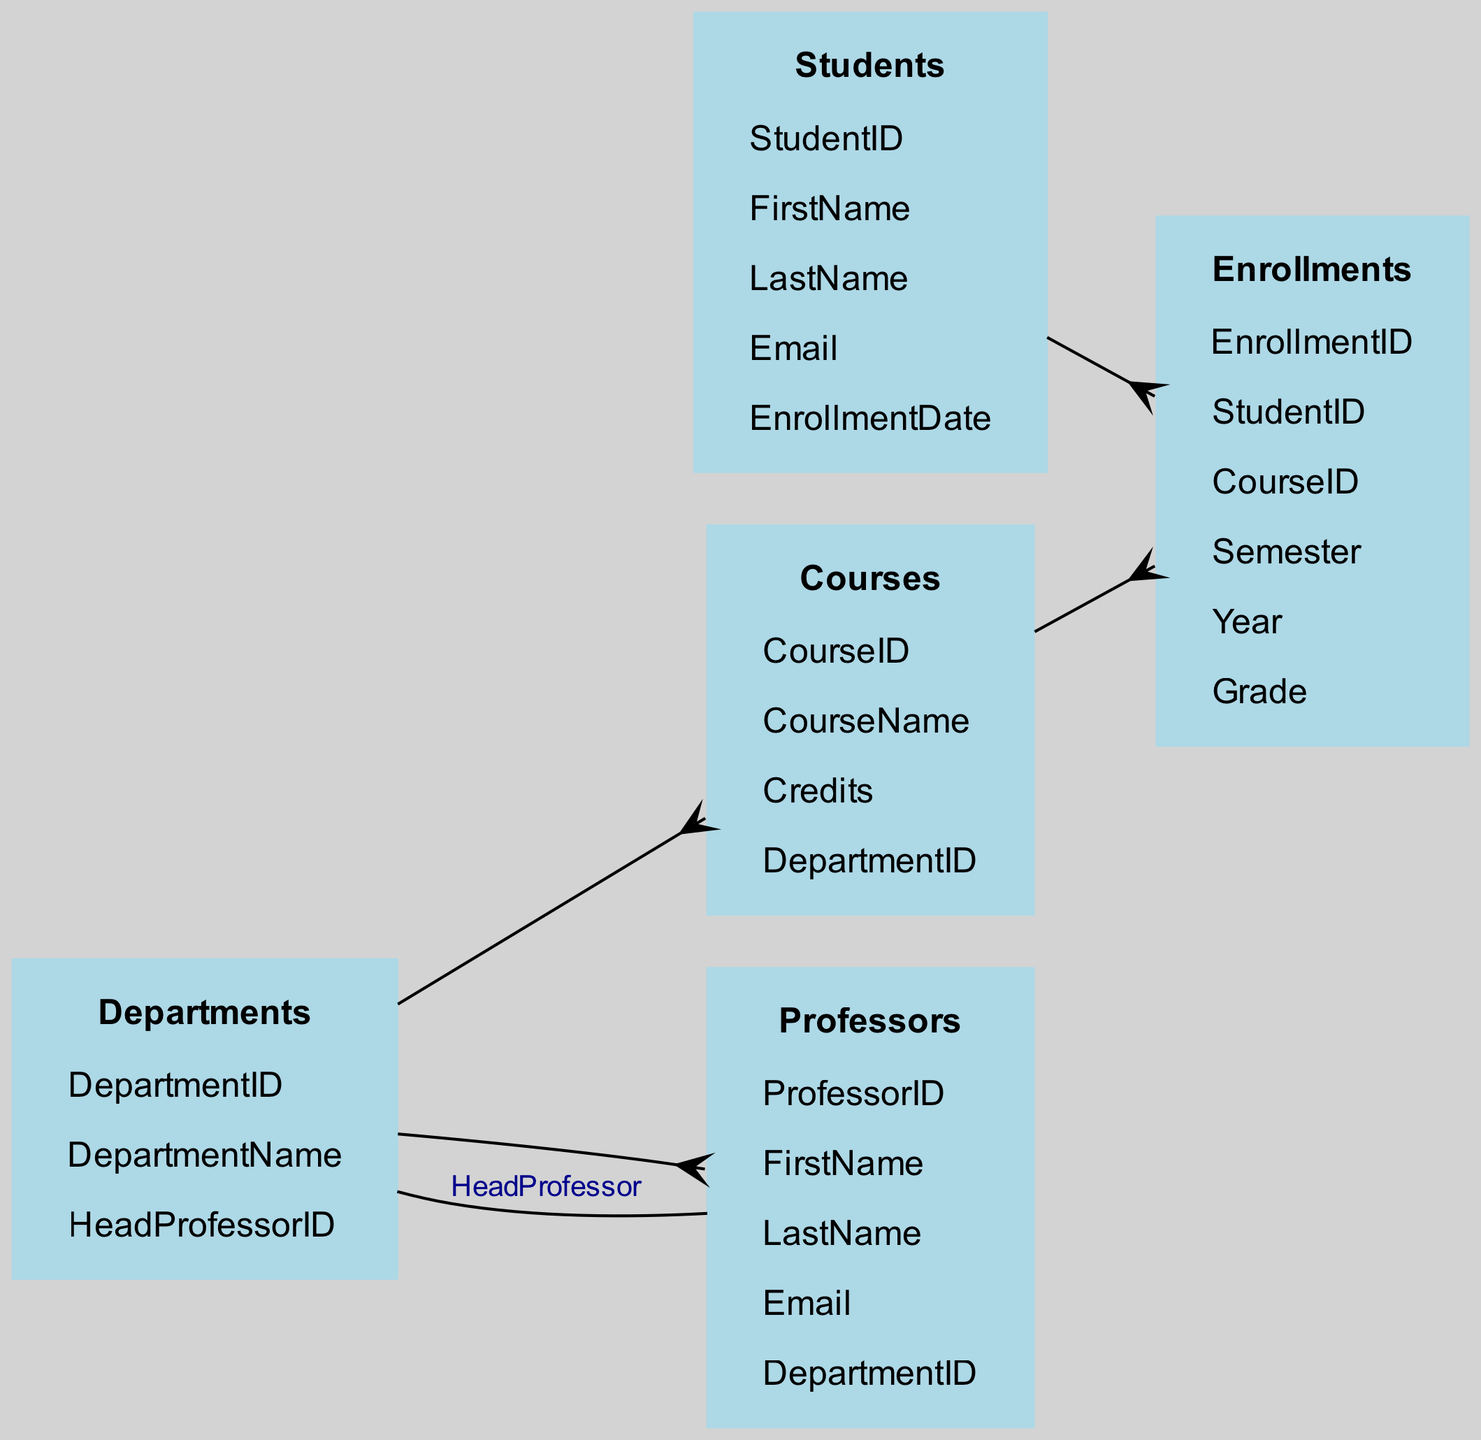What is the total number of tables in the schema? The diagram includes five distinct tables: Students, Courses, Departments, Professors, and Enrollments. The total is thus obtained by counting each of these tables.
Answer: 5 What relationship exists between Students and Enrollments? The diagram illustrates a one-to-many relationship between Students and Enrollments. This means that one student can be enrolled in multiple courses, resulting in multiple entries in the Enrollments table for that student.
Answer: one-to-many Which department is the relationship from Departments to Professors? The diagram specifies a one-to-many relationship from Departments to Professors. This relationship indicates that a department can have multiple professors associated with it, but each professor belongs to only one department.
Answer: one-to-many How many columns does the Courses table have? By examining the Courses table in the diagram, we can note that it has four columns: CourseID, CourseName, Credits, and DepartmentID. Thus, counting these columns gives the answer.
Answer: 4 What is the primary key in the Students table? In the Students table, the primary key is the StudentID, as it uniquely identifies each student in the system. This is a common convention used in relational database design.
Answer: StudentID Who is the head professor of a department? The diagram indicates a one-to-one relationship from Professors to Departments labeled as "HeadProfessor." This denotes that each department has exactly one head professor.
Answer: HeadProfessor In how many semesters can a student enroll according to the schema? A student can enroll in courses across multiple semesters, and while the diagram does not specify a limit, each enrollment entry indicates a specific semester and year. Therefore, theoretically, it can be multiple semesters as long as the student continues their studies.
Answer: multiple Which table does the Enrollments table relate to through CourseID? The Enrollments table has a one-to-many relationship with the Courses table through the CourseID column. This signifies that for each course, numerous students can enroll, leading to several entries in the Enrollments table linked to the same CourseID.
Answer: Courses What is the total number of relationships defined in the schema? The diagram outlines five relationships across different tables, including multiple one-to-many and one-to-one connections. Counting each of these relationships gives the total.
Answer: 5 